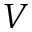Convert formula to latex. <formula><loc_0><loc_0><loc_500><loc_500>V</formula> 